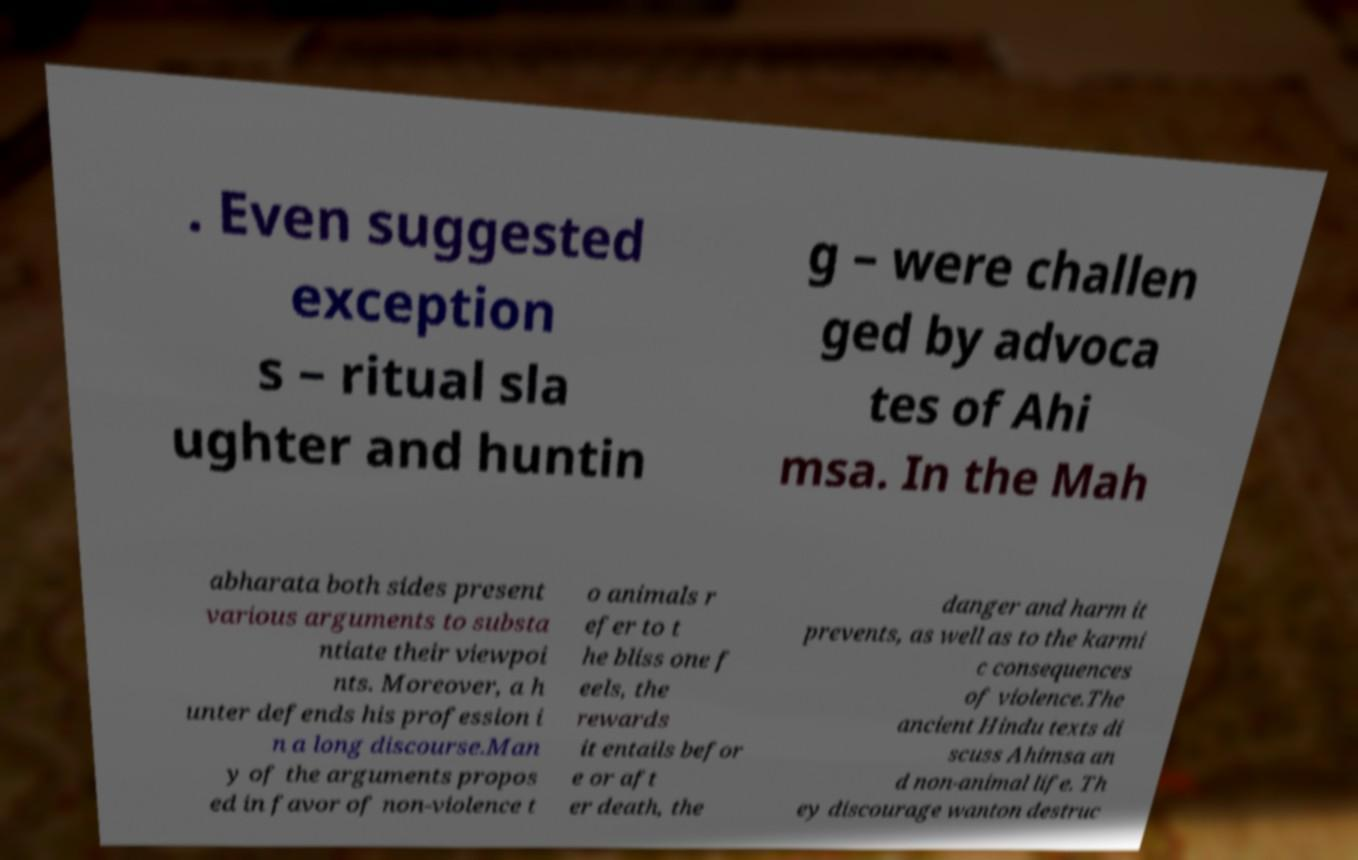Can you read and provide the text displayed in the image?This photo seems to have some interesting text. Can you extract and type it out for me? . Even suggested exception s – ritual sla ughter and huntin g – were challen ged by advoca tes of Ahi msa. In the Mah abharata both sides present various arguments to substa ntiate their viewpoi nts. Moreover, a h unter defends his profession i n a long discourse.Man y of the arguments propos ed in favor of non-violence t o animals r efer to t he bliss one f eels, the rewards it entails befor e or aft er death, the danger and harm it prevents, as well as to the karmi c consequences of violence.The ancient Hindu texts di scuss Ahimsa an d non-animal life. Th ey discourage wanton destruc 